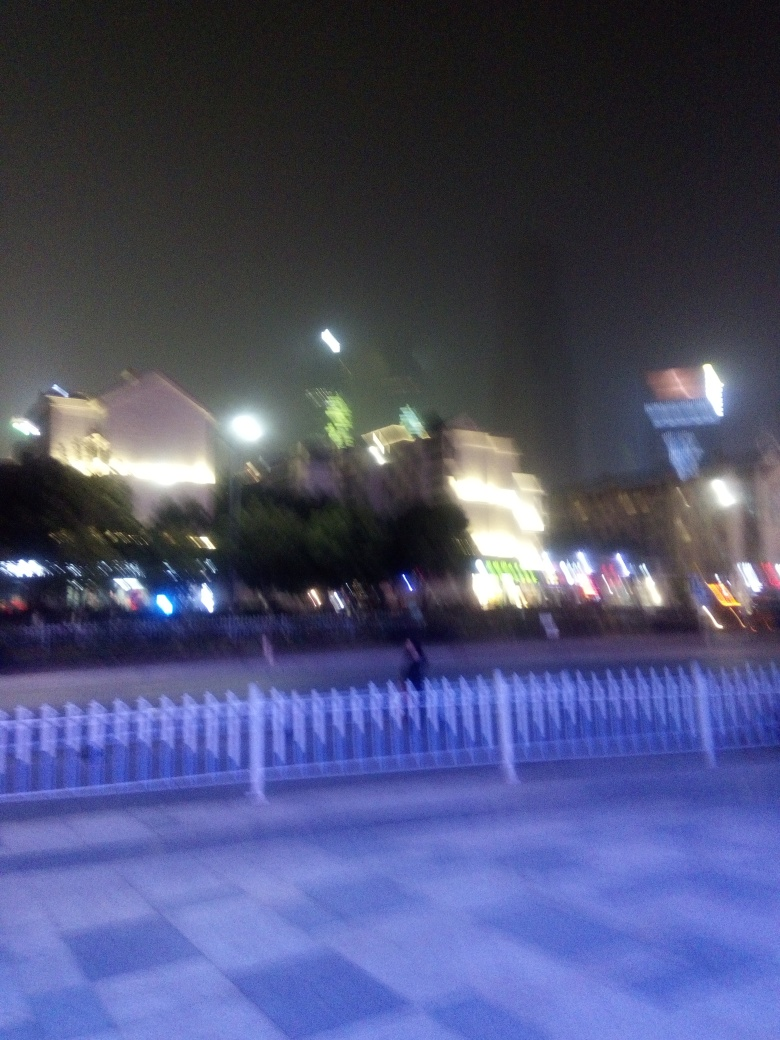Is the background blurry?
 Yes 